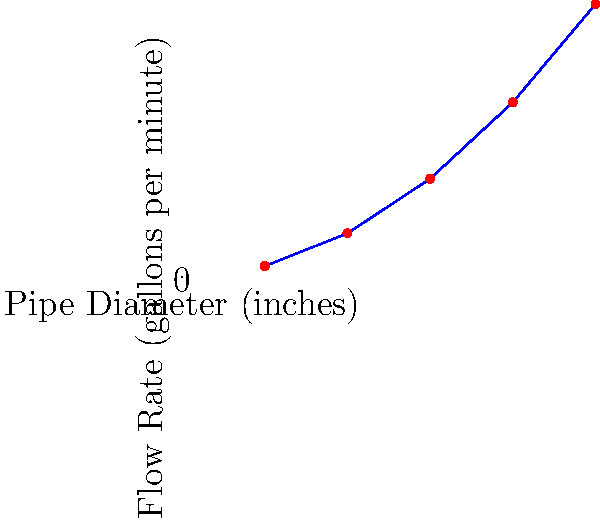The city of Rochester is considering upgrading its water distribution system. The graph shows the relationship between pipe diameter and flow rate in the municipal water system. If the current 6-inch diameter pipes are replaced with 8-inch diameter pipes, approximately how much would the flow rate increase? To solve this problem, we need to follow these steps:

1. Identify the flow rates for 6-inch and 8-inch pipes from the graph:
   - For 6-inch pipe: 450 gallons per minute
   - For 8-inch pipe: 800 gallons per minute

2. Calculate the difference in flow rates:
   $800 - 450 = 350$ gallons per minute

3. Calculate the percentage increase:
   $\text{Percentage increase} = \frac{\text{Increase}}{\text{Original}} \times 100\%$
   $= \frac{350}{450} \times 100\% \approx 77.78\%$

Therefore, replacing the 6-inch pipes with 8-inch pipes would increase the flow rate by approximately 78%.
Answer: 78% 